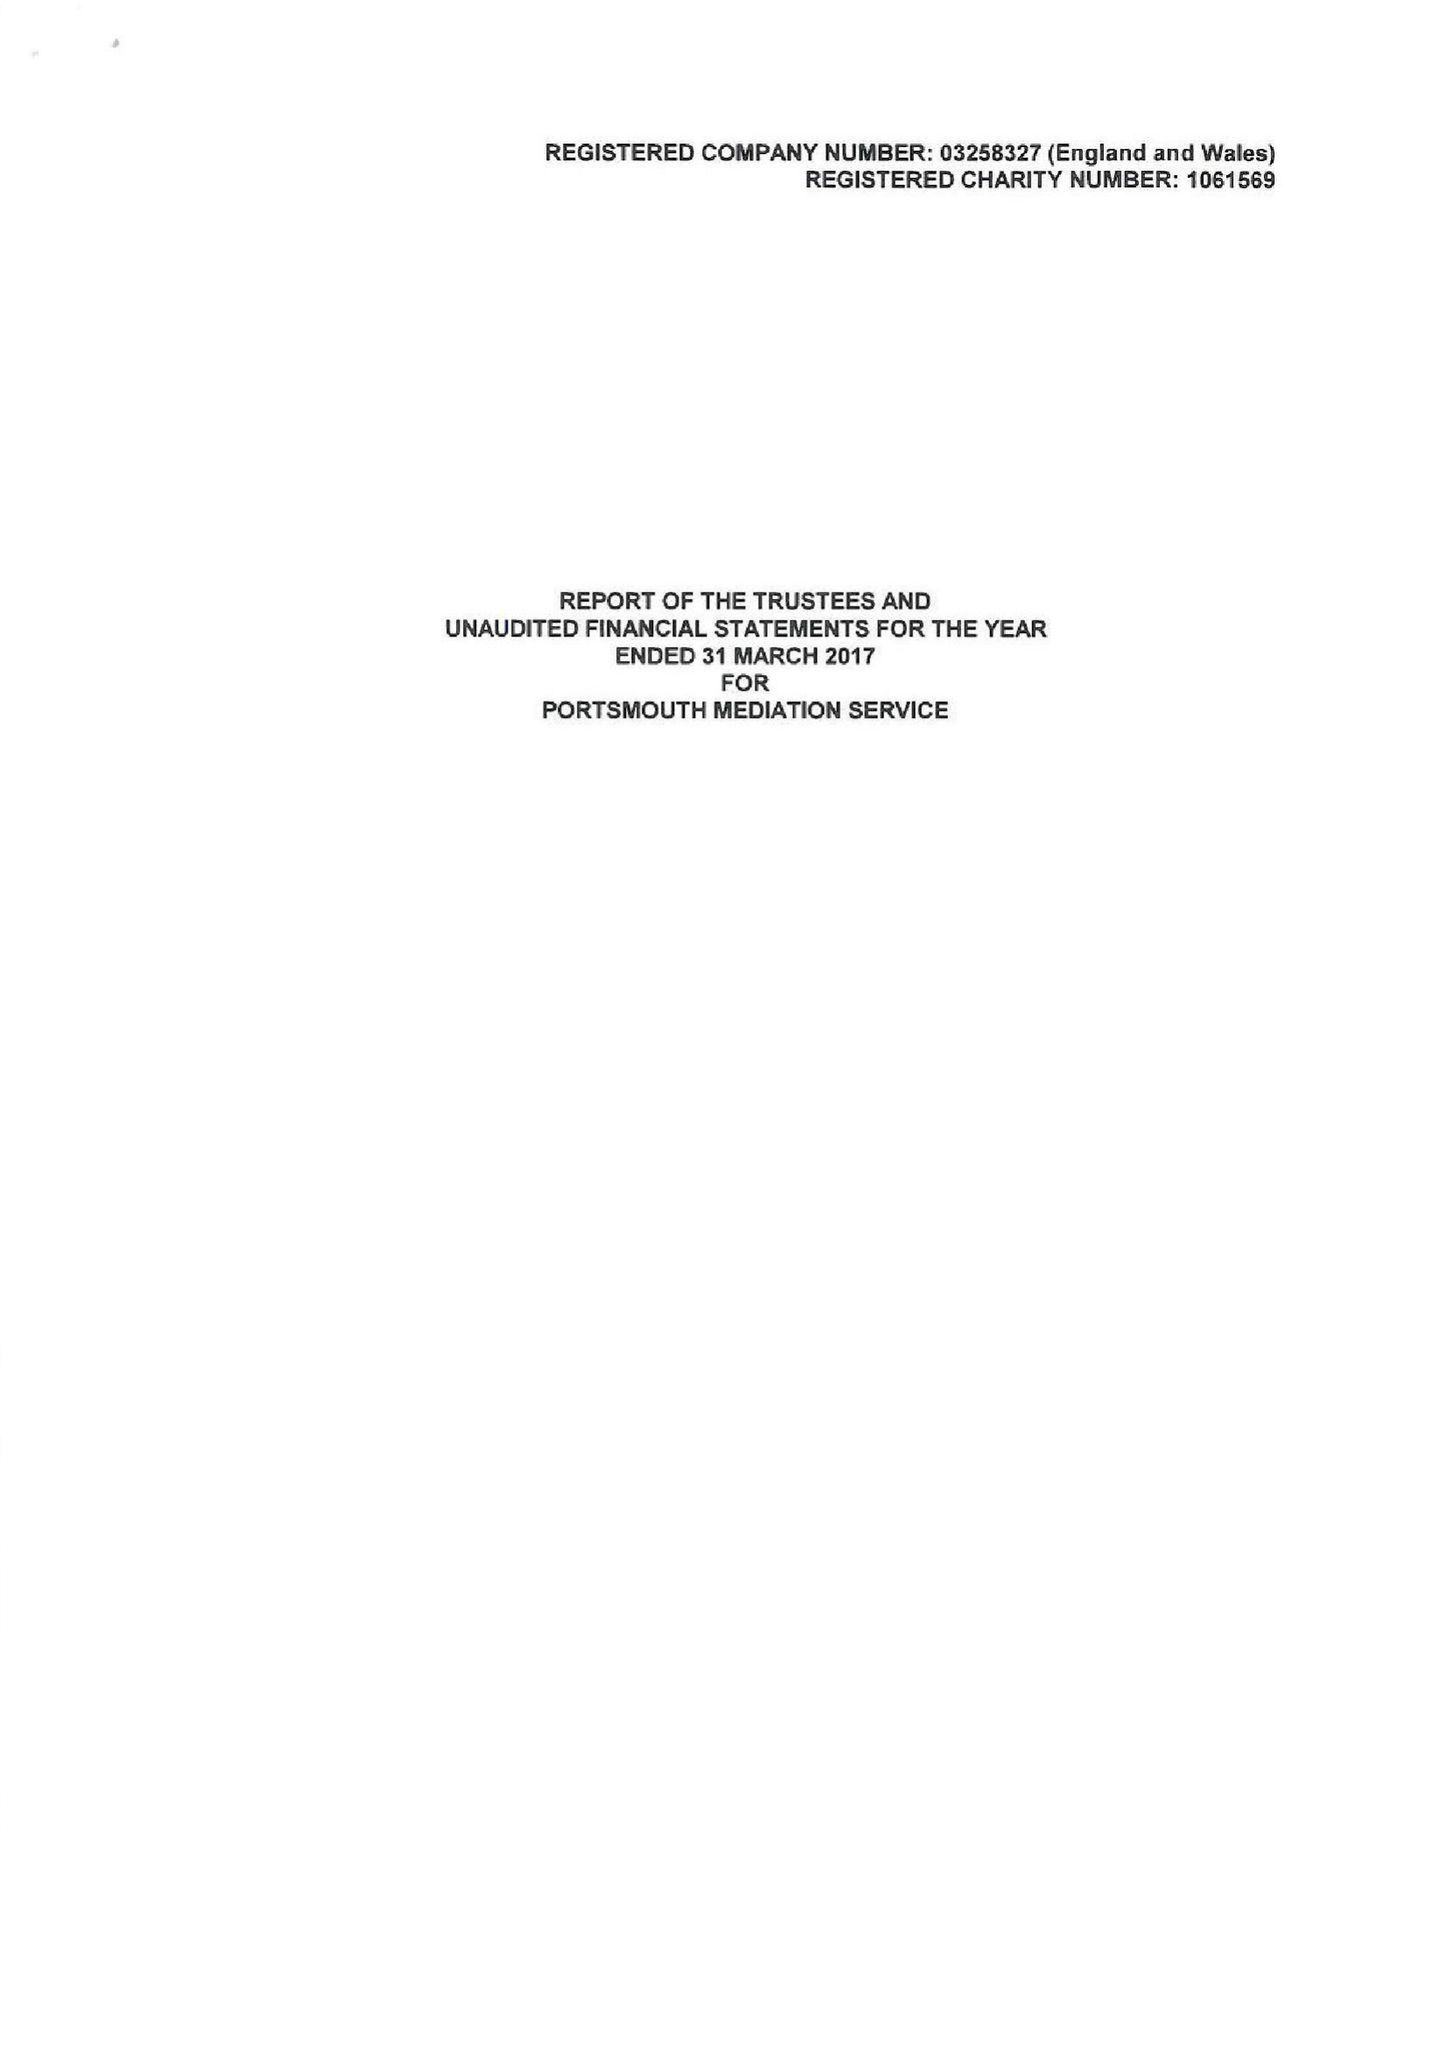What is the value for the address__post_town?
Answer the question using a single word or phrase. PORTSMOUTH 